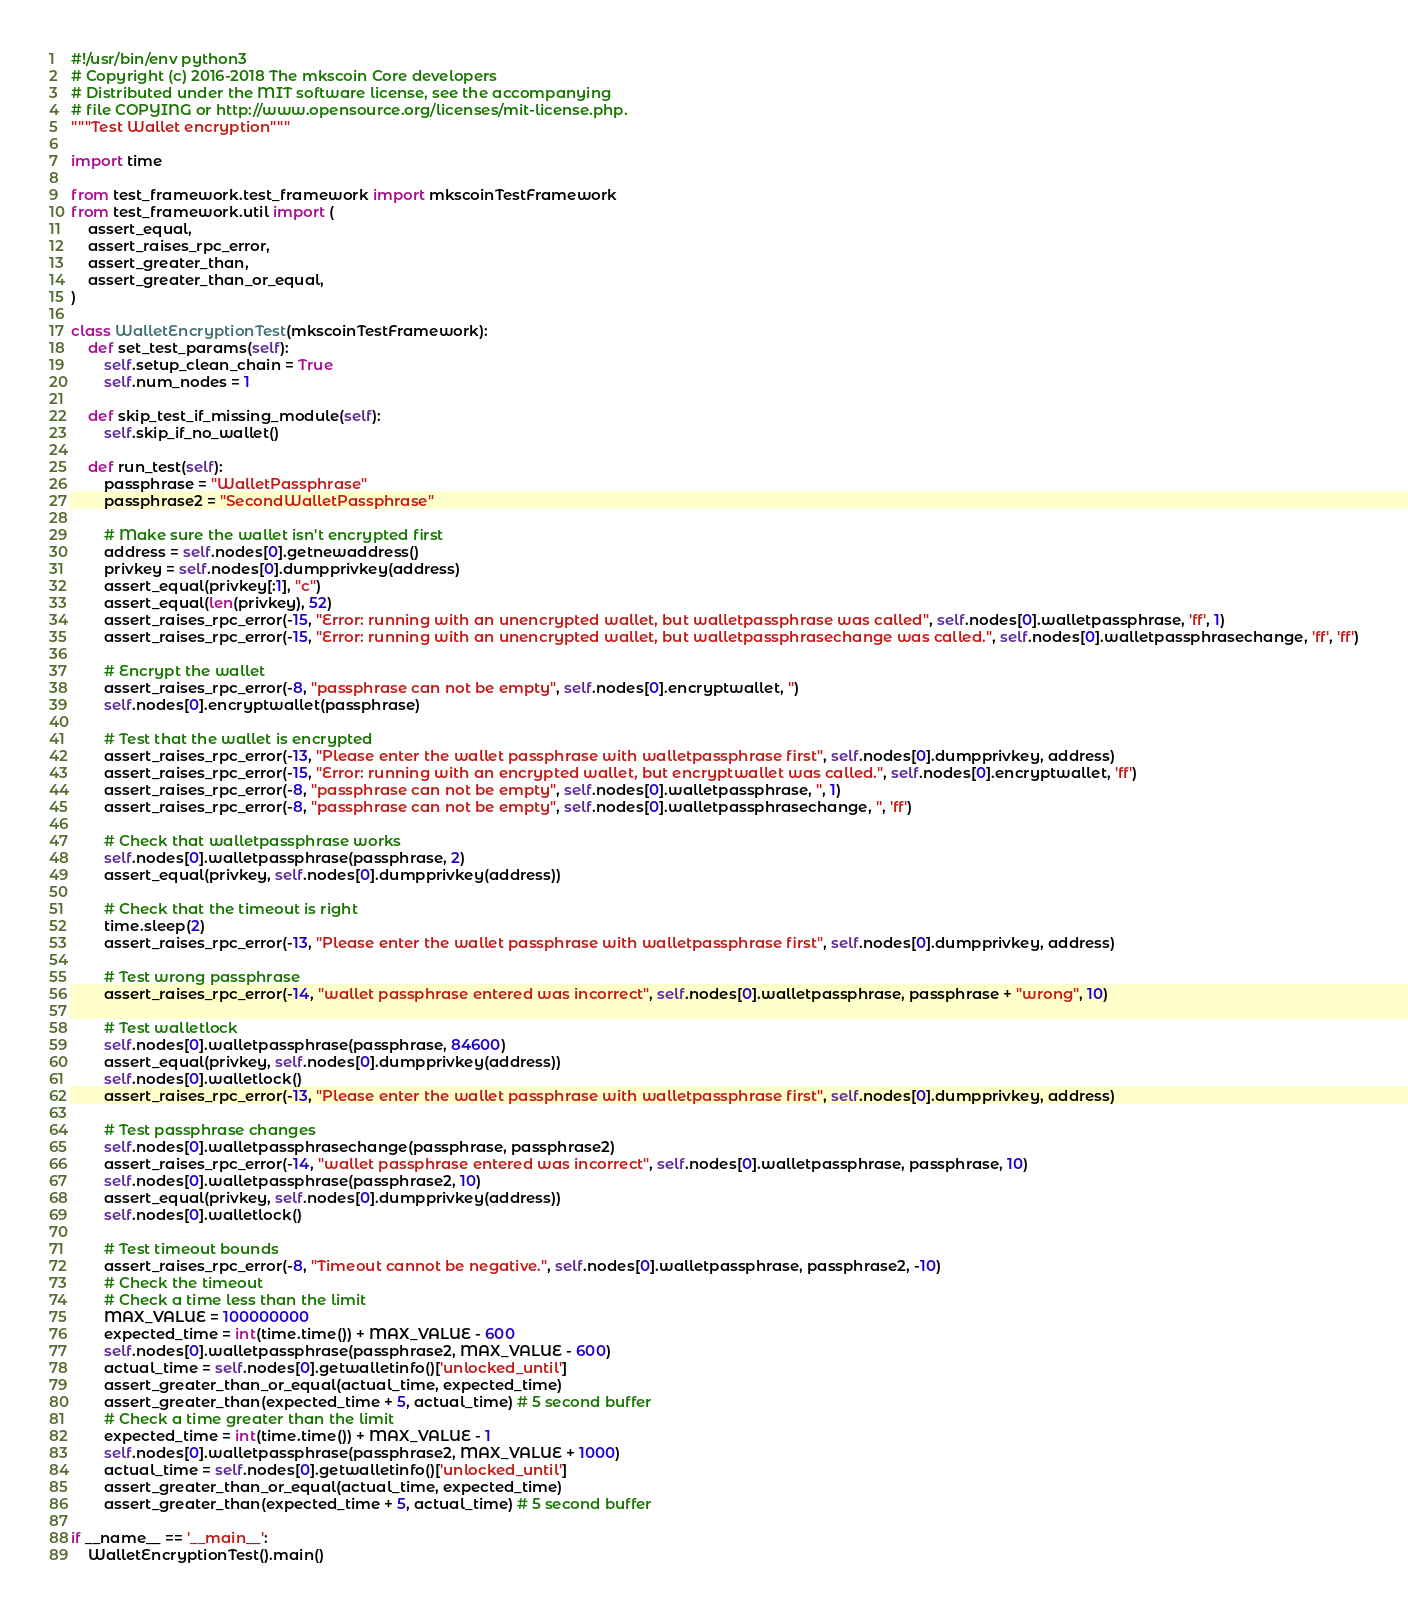Convert code to text. <code><loc_0><loc_0><loc_500><loc_500><_Python_>#!/usr/bin/env python3
# Copyright (c) 2016-2018 The mkscoin Core developers
# Distributed under the MIT software license, see the accompanying
# file COPYING or http://www.opensource.org/licenses/mit-license.php.
"""Test Wallet encryption"""

import time

from test_framework.test_framework import mkscoinTestFramework
from test_framework.util import (
    assert_equal,
    assert_raises_rpc_error,
    assert_greater_than,
    assert_greater_than_or_equal,
)

class WalletEncryptionTest(mkscoinTestFramework):
    def set_test_params(self):
        self.setup_clean_chain = True
        self.num_nodes = 1

    def skip_test_if_missing_module(self):
        self.skip_if_no_wallet()

    def run_test(self):
        passphrase = "WalletPassphrase"
        passphrase2 = "SecondWalletPassphrase"

        # Make sure the wallet isn't encrypted first
        address = self.nodes[0].getnewaddress()
        privkey = self.nodes[0].dumpprivkey(address)
        assert_equal(privkey[:1], "c")
        assert_equal(len(privkey), 52)
        assert_raises_rpc_error(-15, "Error: running with an unencrypted wallet, but walletpassphrase was called", self.nodes[0].walletpassphrase, 'ff', 1)
        assert_raises_rpc_error(-15, "Error: running with an unencrypted wallet, but walletpassphrasechange was called.", self.nodes[0].walletpassphrasechange, 'ff', 'ff')

        # Encrypt the wallet
        assert_raises_rpc_error(-8, "passphrase can not be empty", self.nodes[0].encryptwallet, '')
        self.nodes[0].encryptwallet(passphrase)

        # Test that the wallet is encrypted
        assert_raises_rpc_error(-13, "Please enter the wallet passphrase with walletpassphrase first", self.nodes[0].dumpprivkey, address)
        assert_raises_rpc_error(-15, "Error: running with an encrypted wallet, but encryptwallet was called.", self.nodes[0].encryptwallet, 'ff')
        assert_raises_rpc_error(-8, "passphrase can not be empty", self.nodes[0].walletpassphrase, '', 1)
        assert_raises_rpc_error(-8, "passphrase can not be empty", self.nodes[0].walletpassphrasechange, '', 'ff')

        # Check that walletpassphrase works
        self.nodes[0].walletpassphrase(passphrase, 2)
        assert_equal(privkey, self.nodes[0].dumpprivkey(address))

        # Check that the timeout is right
        time.sleep(2)
        assert_raises_rpc_error(-13, "Please enter the wallet passphrase with walletpassphrase first", self.nodes[0].dumpprivkey, address)

        # Test wrong passphrase
        assert_raises_rpc_error(-14, "wallet passphrase entered was incorrect", self.nodes[0].walletpassphrase, passphrase + "wrong", 10)

        # Test walletlock
        self.nodes[0].walletpassphrase(passphrase, 84600)
        assert_equal(privkey, self.nodes[0].dumpprivkey(address))
        self.nodes[0].walletlock()
        assert_raises_rpc_error(-13, "Please enter the wallet passphrase with walletpassphrase first", self.nodes[0].dumpprivkey, address)

        # Test passphrase changes
        self.nodes[0].walletpassphrasechange(passphrase, passphrase2)
        assert_raises_rpc_error(-14, "wallet passphrase entered was incorrect", self.nodes[0].walletpassphrase, passphrase, 10)
        self.nodes[0].walletpassphrase(passphrase2, 10)
        assert_equal(privkey, self.nodes[0].dumpprivkey(address))
        self.nodes[0].walletlock()

        # Test timeout bounds
        assert_raises_rpc_error(-8, "Timeout cannot be negative.", self.nodes[0].walletpassphrase, passphrase2, -10)
        # Check the timeout
        # Check a time less than the limit
        MAX_VALUE = 100000000
        expected_time = int(time.time()) + MAX_VALUE - 600
        self.nodes[0].walletpassphrase(passphrase2, MAX_VALUE - 600)
        actual_time = self.nodes[0].getwalletinfo()['unlocked_until']
        assert_greater_than_or_equal(actual_time, expected_time)
        assert_greater_than(expected_time + 5, actual_time) # 5 second buffer
        # Check a time greater than the limit
        expected_time = int(time.time()) + MAX_VALUE - 1
        self.nodes[0].walletpassphrase(passphrase2, MAX_VALUE + 1000)
        actual_time = self.nodes[0].getwalletinfo()['unlocked_until']
        assert_greater_than_or_equal(actual_time, expected_time)
        assert_greater_than(expected_time + 5, actual_time) # 5 second buffer

if __name__ == '__main__':
    WalletEncryptionTest().main()
</code> 